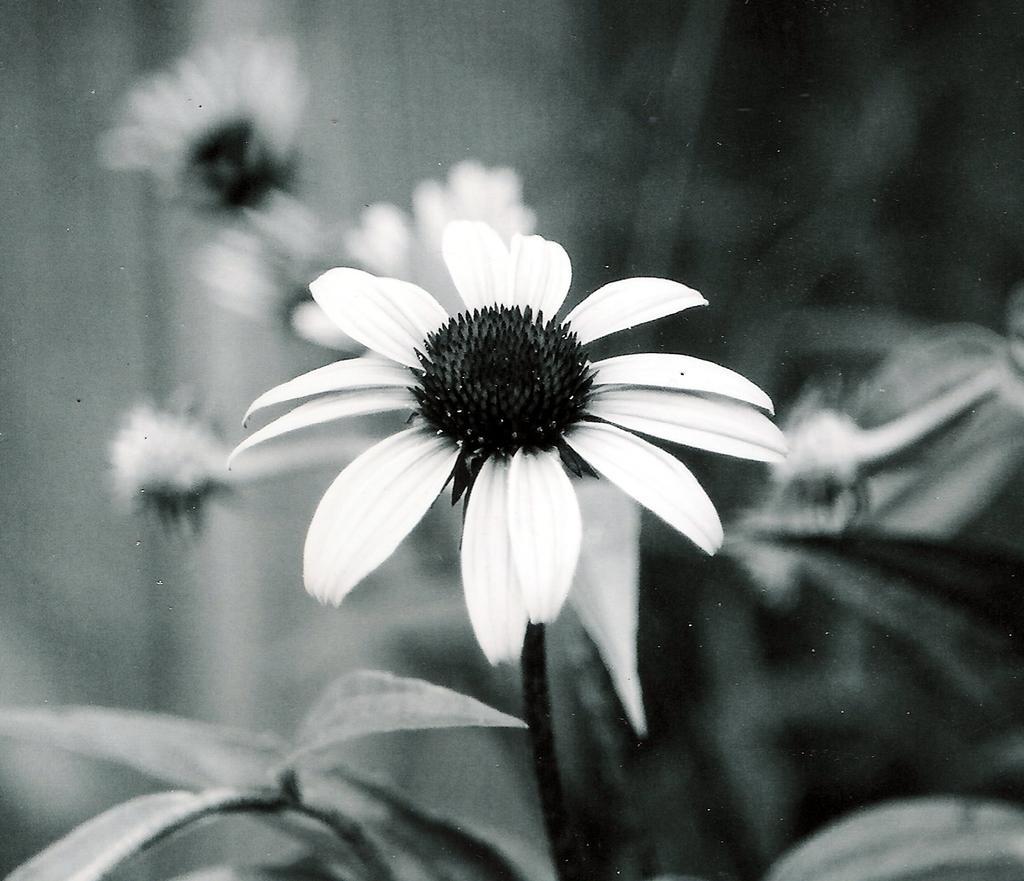In one or two sentences, can you explain what this image depicts? This is black and white image. In this we can see flower, leaves and stem. The background is blurry. 